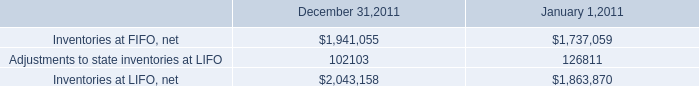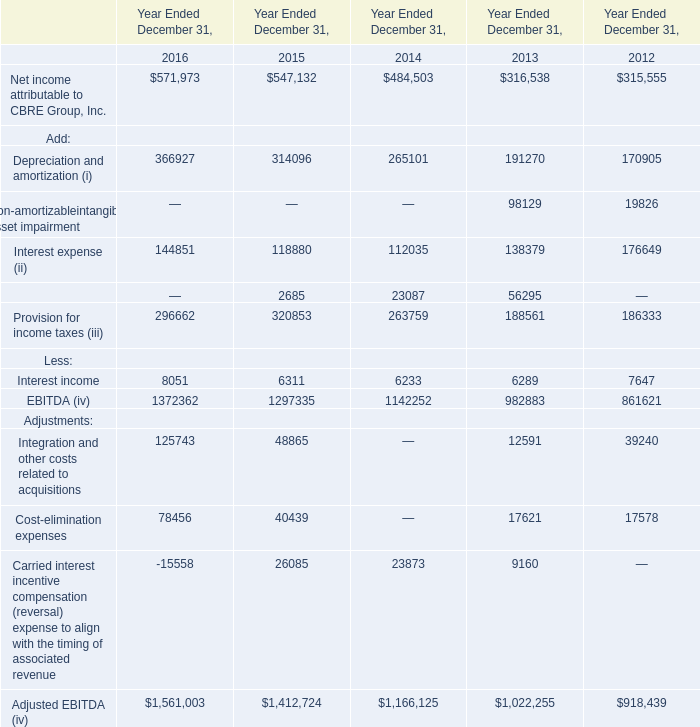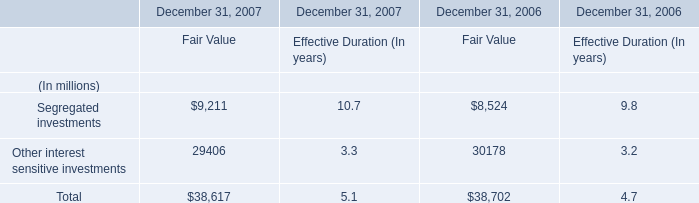If Depreciation and amortization (i) develops with the same growth rate in 2016, what will it reach in 2017? 
Computations: (366927 * (1 + ((366927 - 314096) / 314096)))
Answer: 428644.18308. 